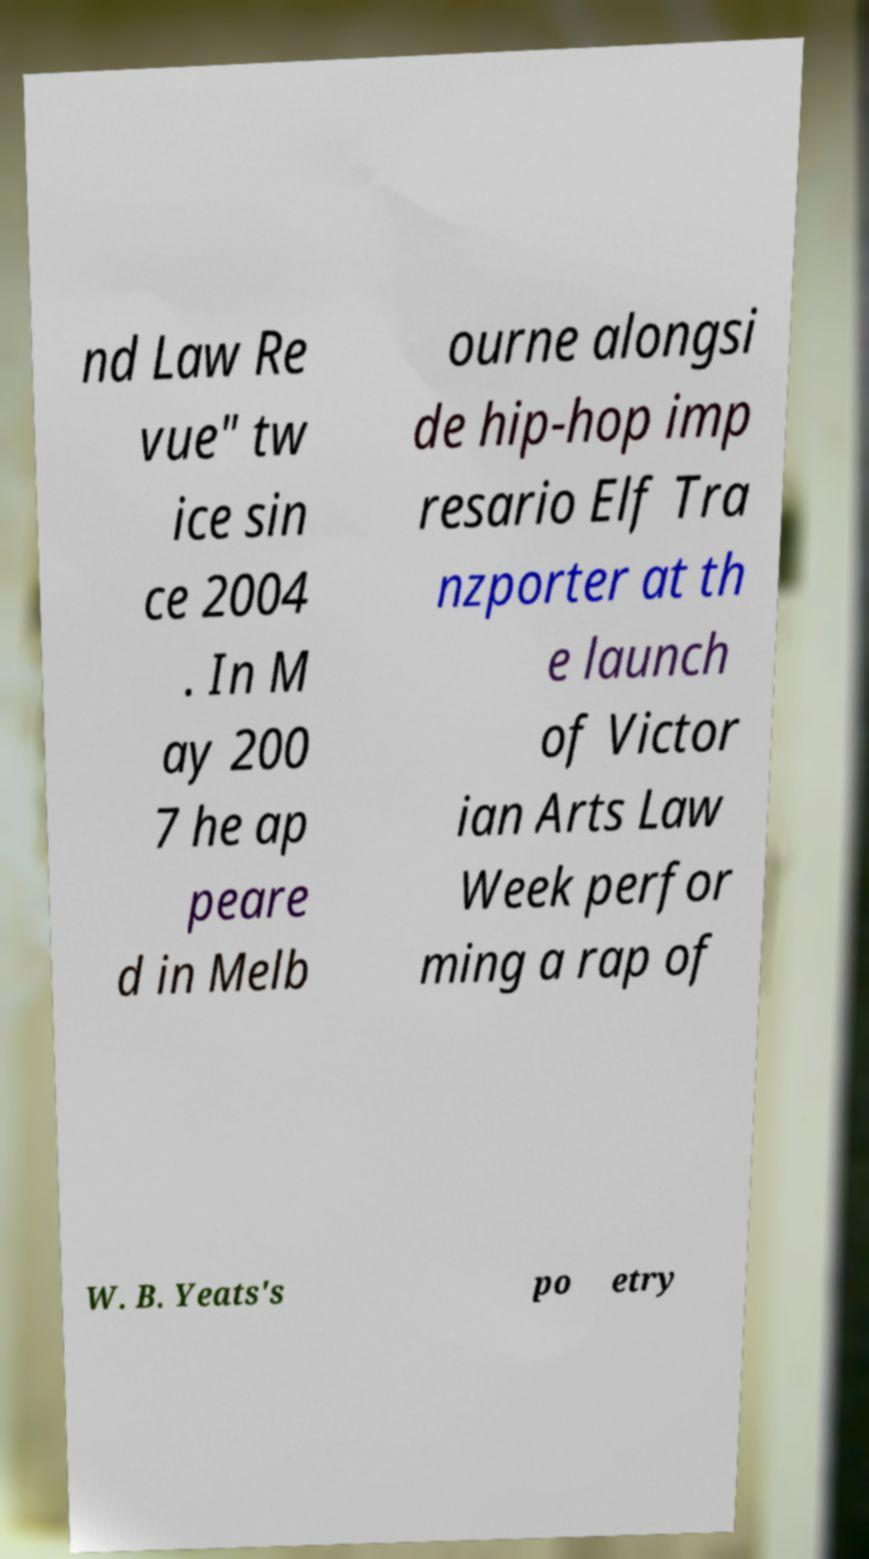What messages or text are displayed in this image? I need them in a readable, typed format. nd Law Re vue" tw ice sin ce 2004 . In M ay 200 7 he ap peare d in Melb ourne alongsi de hip-hop imp resario Elf Tra nzporter at th e launch of Victor ian Arts Law Week perfor ming a rap of W. B. Yeats's po etry 